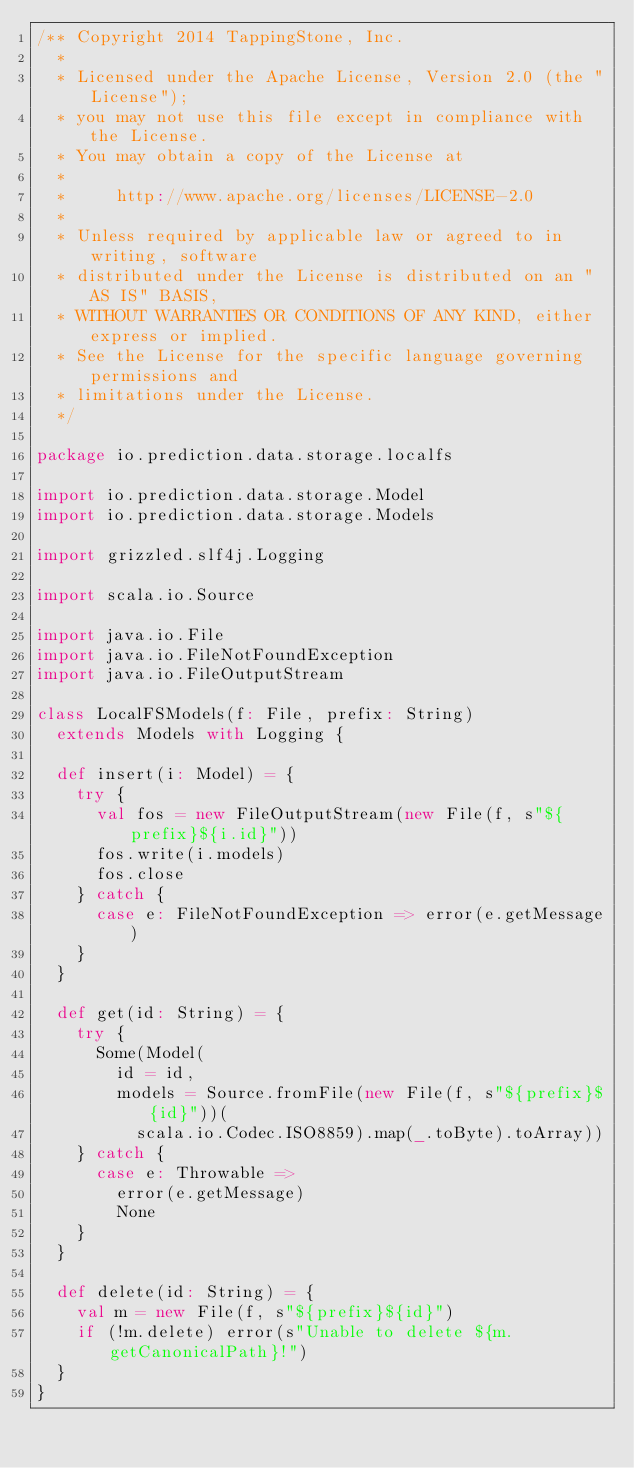<code> <loc_0><loc_0><loc_500><loc_500><_Scala_>/** Copyright 2014 TappingStone, Inc.
  *
  * Licensed under the Apache License, Version 2.0 (the "License");
  * you may not use this file except in compliance with the License.
  * You may obtain a copy of the License at
  *
  *     http://www.apache.org/licenses/LICENSE-2.0
  *
  * Unless required by applicable law or agreed to in writing, software
  * distributed under the License is distributed on an "AS IS" BASIS,
  * WITHOUT WARRANTIES OR CONDITIONS OF ANY KIND, either express or implied.
  * See the License for the specific language governing permissions and
  * limitations under the License.
  */

package io.prediction.data.storage.localfs

import io.prediction.data.storage.Model
import io.prediction.data.storage.Models

import grizzled.slf4j.Logging

import scala.io.Source

import java.io.File
import java.io.FileNotFoundException
import java.io.FileOutputStream

class LocalFSModels(f: File, prefix: String)
  extends Models with Logging {

  def insert(i: Model) = {
    try {
      val fos = new FileOutputStream(new File(f, s"${prefix}${i.id}"))
      fos.write(i.models)
      fos.close
    } catch {
      case e: FileNotFoundException => error(e.getMessage)
    }
  }

  def get(id: String) = {
    try {
      Some(Model(
        id = id,
        models = Source.fromFile(new File(f, s"${prefix}${id}"))(
          scala.io.Codec.ISO8859).map(_.toByte).toArray))
    } catch {
      case e: Throwable =>
        error(e.getMessage)
        None
    }
  }

  def delete(id: String) = {
    val m = new File(f, s"${prefix}${id}")
    if (!m.delete) error(s"Unable to delete ${m.getCanonicalPath}!")
  }
}
</code> 